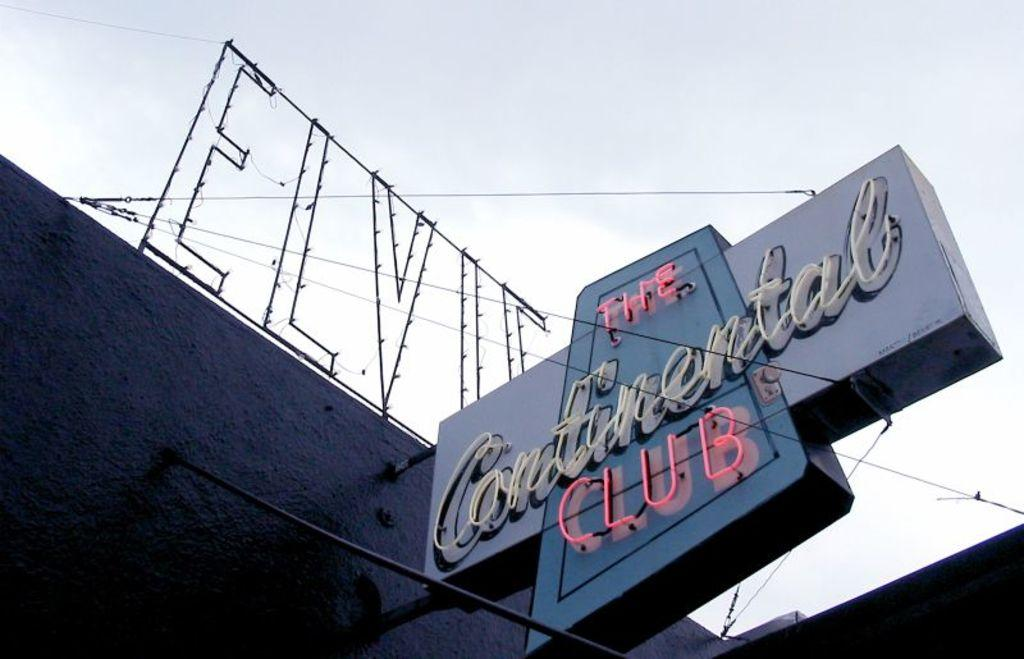<image>
Share a concise interpretation of the image provided. A sign for the Continental Club with Elvis' name above it 